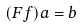Convert formula to latex. <formula><loc_0><loc_0><loc_500><loc_500>( F f ) a = b</formula> 